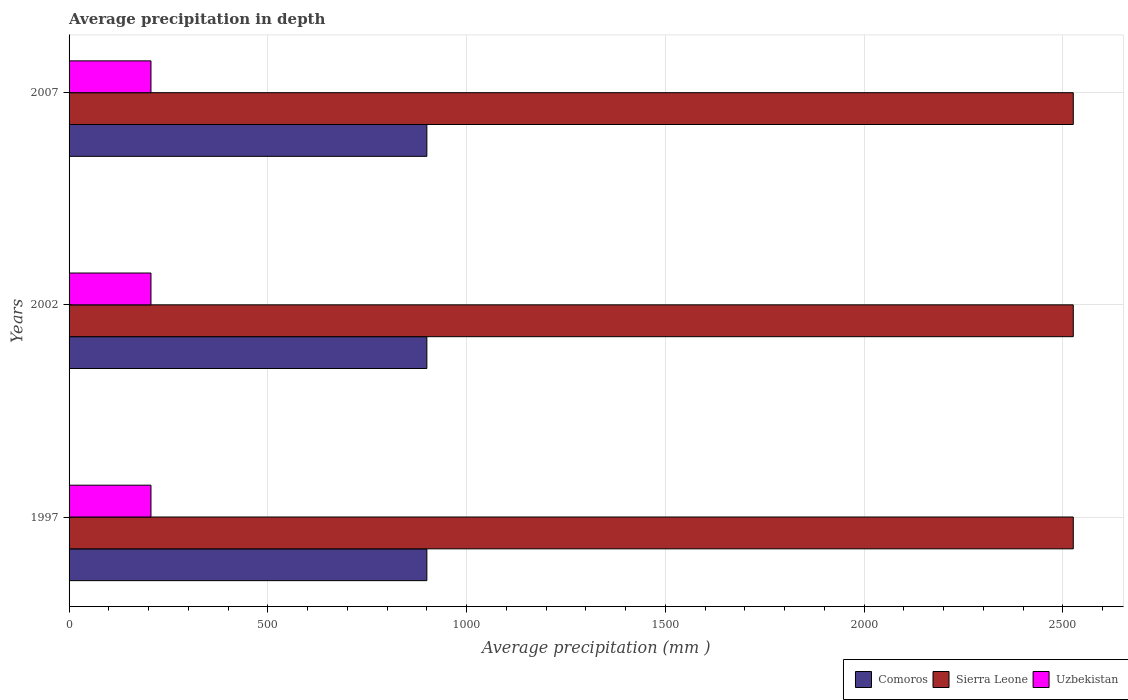How many bars are there on the 1st tick from the top?
Your answer should be very brief. 3. What is the label of the 3rd group of bars from the top?
Provide a short and direct response. 1997. In how many cases, is the number of bars for a given year not equal to the number of legend labels?
Offer a terse response. 0. What is the average precipitation in Comoros in 2007?
Keep it short and to the point. 900. Across all years, what is the maximum average precipitation in Comoros?
Keep it short and to the point. 900. Across all years, what is the minimum average precipitation in Uzbekistan?
Your answer should be compact. 206. In which year was the average precipitation in Sierra Leone minimum?
Your answer should be very brief. 1997. What is the total average precipitation in Uzbekistan in the graph?
Provide a short and direct response. 618. What is the difference between the average precipitation in Uzbekistan in 2007 and the average precipitation in Comoros in 1997?
Ensure brevity in your answer.  -694. What is the average average precipitation in Uzbekistan per year?
Give a very brief answer. 206. In the year 2007, what is the difference between the average precipitation in Sierra Leone and average precipitation in Uzbekistan?
Offer a terse response. 2320. In how many years, is the average precipitation in Uzbekistan greater than 700 mm?
Your answer should be compact. 0. What is the ratio of the average precipitation in Uzbekistan in 1997 to that in 2002?
Ensure brevity in your answer.  1. Is the difference between the average precipitation in Sierra Leone in 1997 and 2007 greater than the difference between the average precipitation in Uzbekistan in 1997 and 2007?
Your answer should be very brief. No. Is the sum of the average precipitation in Uzbekistan in 2002 and 2007 greater than the maximum average precipitation in Comoros across all years?
Your response must be concise. No. What does the 2nd bar from the top in 2002 represents?
Offer a terse response. Sierra Leone. What does the 2nd bar from the bottom in 2002 represents?
Provide a succinct answer. Sierra Leone. How many years are there in the graph?
Your answer should be compact. 3. Are the values on the major ticks of X-axis written in scientific E-notation?
Your answer should be compact. No. Does the graph contain grids?
Provide a succinct answer. Yes. Where does the legend appear in the graph?
Provide a short and direct response. Bottom right. What is the title of the graph?
Offer a very short reply. Average precipitation in depth. Does "Vanuatu" appear as one of the legend labels in the graph?
Give a very brief answer. No. What is the label or title of the X-axis?
Your answer should be compact. Average precipitation (mm ). What is the label or title of the Y-axis?
Offer a very short reply. Years. What is the Average precipitation (mm ) in Comoros in 1997?
Your answer should be very brief. 900. What is the Average precipitation (mm ) of Sierra Leone in 1997?
Your response must be concise. 2526. What is the Average precipitation (mm ) of Uzbekistan in 1997?
Your answer should be very brief. 206. What is the Average precipitation (mm ) in Comoros in 2002?
Keep it short and to the point. 900. What is the Average precipitation (mm ) in Sierra Leone in 2002?
Your answer should be compact. 2526. What is the Average precipitation (mm ) in Uzbekistan in 2002?
Keep it short and to the point. 206. What is the Average precipitation (mm ) in Comoros in 2007?
Make the answer very short. 900. What is the Average precipitation (mm ) of Sierra Leone in 2007?
Give a very brief answer. 2526. What is the Average precipitation (mm ) of Uzbekistan in 2007?
Ensure brevity in your answer.  206. Across all years, what is the maximum Average precipitation (mm ) of Comoros?
Give a very brief answer. 900. Across all years, what is the maximum Average precipitation (mm ) in Sierra Leone?
Make the answer very short. 2526. Across all years, what is the maximum Average precipitation (mm ) in Uzbekistan?
Keep it short and to the point. 206. Across all years, what is the minimum Average precipitation (mm ) in Comoros?
Provide a short and direct response. 900. Across all years, what is the minimum Average precipitation (mm ) in Sierra Leone?
Give a very brief answer. 2526. Across all years, what is the minimum Average precipitation (mm ) in Uzbekistan?
Make the answer very short. 206. What is the total Average precipitation (mm ) in Comoros in the graph?
Make the answer very short. 2700. What is the total Average precipitation (mm ) of Sierra Leone in the graph?
Your answer should be compact. 7578. What is the total Average precipitation (mm ) of Uzbekistan in the graph?
Offer a very short reply. 618. What is the difference between the Average precipitation (mm ) of Comoros in 1997 and that in 2002?
Provide a succinct answer. 0. What is the difference between the Average precipitation (mm ) of Uzbekistan in 1997 and that in 2002?
Offer a very short reply. 0. What is the difference between the Average precipitation (mm ) in Comoros in 1997 and that in 2007?
Your response must be concise. 0. What is the difference between the Average precipitation (mm ) of Comoros in 2002 and that in 2007?
Your answer should be compact. 0. What is the difference between the Average precipitation (mm ) of Comoros in 1997 and the Average precipitation (mm ) of Sierra Leone in 2002?
Your answer should be very brief. -1626. What is the difference between the Average precipitation (mm ) in Comoros in 1997 and the Average precipitation (mm ) in Uzbekistan in 2002?
Make the answer very short. 694. What is the difference between the Average precipitation (mm ) in Sierra Leone in 1997 and the Average precipitation (mm ) in Uzbekistan in 2002?
Your response must be concise. 2320. What is the difference between the Average precipitation (mm ) in Comoros in 1997 and the Average precipitation (mm ) in Sierra Leone in 2007?
Offer a very short reply. -1626. What is the difference between the Average precipitation (mm ) of Comoros in 1997 and the Average precipitation (mm ) of Uzbekistan in 2007?
Keep it short and to the point. 694. What is the difference between the Average precipitation (mm ) of Sierra Leone in 1997 and the Average precipitation (mm ) of Uzbekistan in 2007?
Your answer should be very brief. 2320. What is the difference between the Average precipitation (mm ) in Comoros in 2002 and the Average precipitation (mm ) in Sierra Leone in 2007?
Your answer should be very brief. -1626. What is the difference between the Average precipitation (mm ) of Comoros in 2002 and the Average precipitation (mm ) of Uzbekistan in 2007?
Your response must be concise. 694. What is the difference between the Average precipitation (mm ) of Sierra Leone in 2002 and the Average precipitation (mm ) of Uzbekistan in 2007?
Offer a terse response. 2320. What is the average Average precipitation (mm ) of Comoros per year?
Your answer should be compact. 900. What is the average Average precipitation (mm ) of Sierra Leone per year?
Provide a short and direct response. 2526. What is the average Average precipitation (mm ) in Uzbekistan per year?
Make the answer very short. 206. In the year 1997, what is the difference between the Average precipitation (mm ) in Comoros and Average precipitation (mm ) in Sierra Leone?
Make the answer very short. -1626. In the year 1997, what is the difference between the Average precipitation (mm ) in Comoros and Average precipitation (mm ) in Uzbekistan?
Make the answer very short. 694. In the year 1997, what is the difference between the Average precipitation (mm ) in Sierra Leone and Average precipitation (mm ) in Uzbekistan?
Make the answer very short. 2320. In the year 2002, what is the difference between the Average precipitation (mm ) of Comoros and Average precipitation (mm ) of Sierra Leone?
Your answer should be compact. -1626. In the year 2002, what is the difference between the Average precipitation (mm ) in Comoros and Average precipitation (mm ) in Uzbekistan?
Your answer should be compact. 694. In the year 2002, what is the difference between the Average precipitation (mm ) of Sierra Leone and Average precipitation (mm ) of Uzbekistan?
Give a very brief answer. 2320. In the year 2007, what is the difference between the Average precipitation (mm ) of Comoros and Average precipitation (mm ) of Sierra Leone?
Provide a succinct answer. -1626. In the year 2007, what is the difference between the Average precipitation (mm ) of Comoros and Average precipitation (mm ) of Uzbekistan?
Keep it short and to the point. 694. In the year 2007, what is the difference between the Average precipitation (mm ) of Sierra Leone and Average precipitation (mm ) of Uzbekistan?
Offer a terse response. 2320. What is the ratio of the Average precipitation (mm ) in Sierra Leone in 1997 to that in 2002?
Keep it short and to the point. 1. What is the ratio of the Average precipitation (mm ) of Uzbekistan in 1997 to that in 2002?
Your answer should be compact. 1. What is the ratio of the Average precipitation (mm ) of Uzbekistan in 1997 to that in 2007?
Ensure brevity in your answer.  1. What is the ratio of the Average precipitation (mm ) in Comoros in 2002 to that in 2007?
Provide a succinct answer. 1. What is the difference between the highest and the second highest Average precipitation (mm ) in Sierra Leone?
Keep it short and to the point. 0. What is the difference between the highest and the lowest Average precipitation (mm ) in Uzbekistan?
Give a very brief answer. 0. 